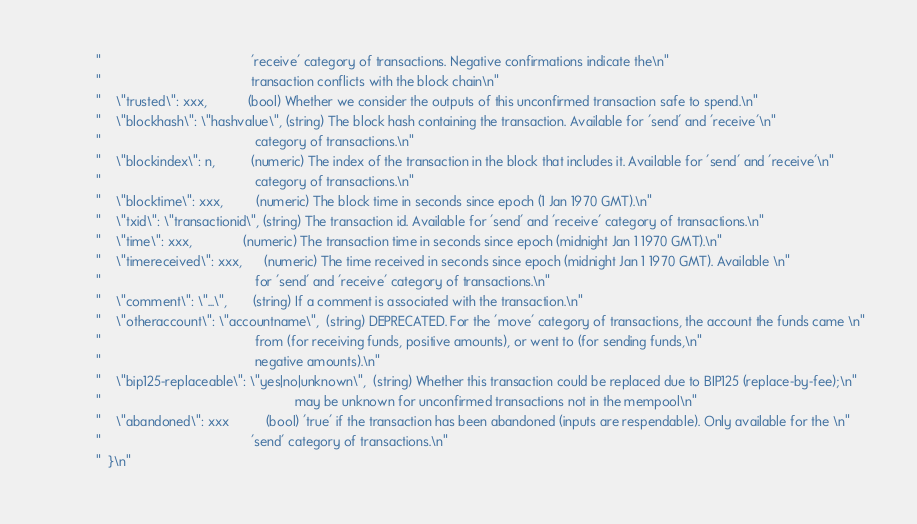<code> <loc_0><loc_0><loc_500><loc_500><_C++_>            "                                         'receive' category of transactions. Negative confirmations indicate the\n"
            "                                         transaction conflicts with the block chain\n"
            "    \"trusted\": xxx,           (bool) Whether we consider the outputs of this unconfirmed transaction safe to spend.\n"
            "    \"blockhash\": \"hashvalue\", (string) The block hash containing the transaction. Available for 'send' and 'receive'\n"
            "                                          category of transactions.\n"
            "    \"blockindex\": n,          (numeric) The index of the transaction in the block that includes it. Available for 'send' and 'receive'\n"
            "                                          category of transactions.\n"
            "    \"blocktime\": xxx,         (numeric) The block time in seconds since epoch (1 Jan 1970 GMT).\n"
            "    \"txid\": \"transactionid\", (string) The transaction id. Available for 'send' and 'receive' category of transactions.\n"
            "    \"time\": xxx,              (numeric) The transaction time in seconds since epoch (midnight Jan 1 1970 GMT).\n"
            "    \"timereceived\": xxx,      (numeric) The time received in seconds since epoch (midnight Jan 1 1970 GMT). Available \n"
            "                                          for 'send' and 'receive' category of transactions.\n"
            "    \"comment\": \"...\",       (string) If a comment is associated with the transaction.\n"
            "    \"otheraccount\": \"accountname\",  (string) DEPRECATED. For the 'move' category of transactions, the account the funds came \n"
            "                                          from (for receiving funds, positive amounts), or went to (for sending funds,\n"
            "                                          negative amounts).\n"
            "    \"bip125-replaceable\": \"yes|no|unknown\",  (string) Whether this transaction could be replaced due to BIP125 (replace-by-fee);\n"
            "                                                     may be unknown for unconfirmed transactions not in the mempool\n"
            "    \"abandoned\": xxx          (bool) 'true' if the transaction has been abandoned (inputs are respendable). Only available for the \n"
            "                                         'send' category of transactions.\n"
            "  }\n"</code> 